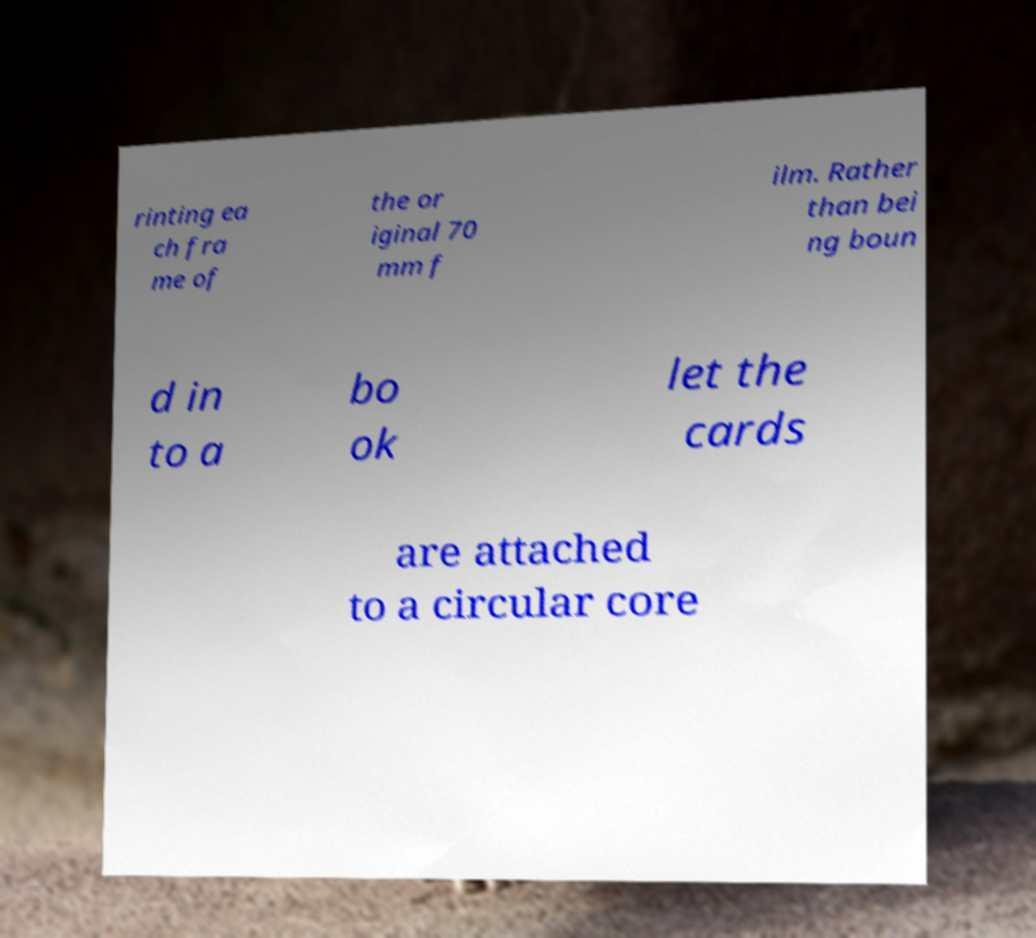Can you accurately transcribe the text from the provided image for me? rinting ea ch fra me of the or iginal 70 mm f ilm. Rather than bei ng boun d in to a bo ok let the cards are attached to a circular core 